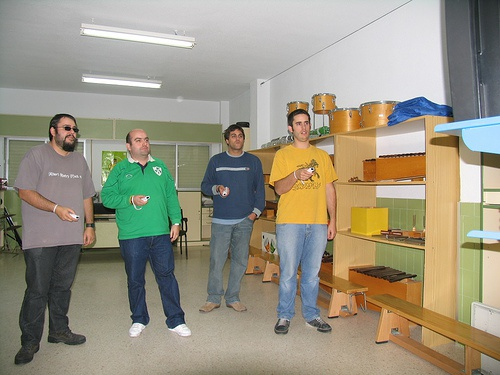Describe the objects in this image and their specific colors. I can see people in gray and black tones, people in gray, green, navy, blue, and black tones, people in gray, orange, and darkgray tones, people in gray and darkblue tones, and tv in gray, black, and purple tones in this image. 